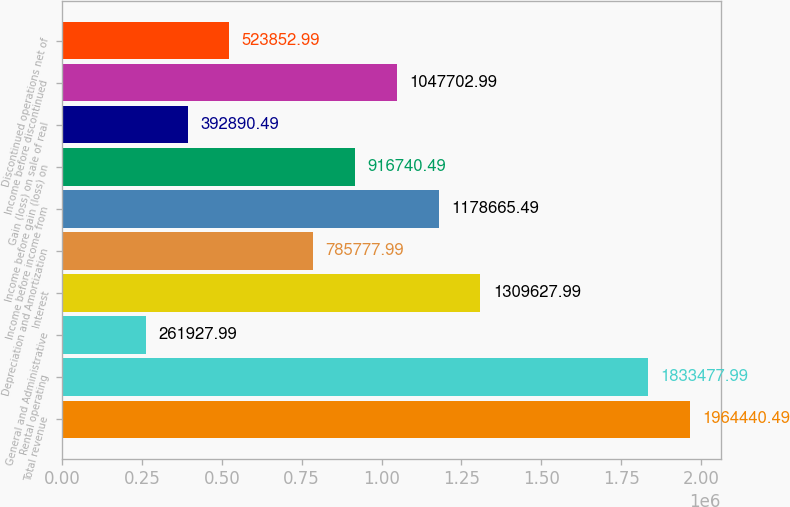Convert chart to OTSL. <chart><loc_0><loc_0><loc_500><loc_500><bar_chart><fcel>Total revenue<fcel>Rental operating<fcel>General and Administrative<fcel>Interest<fcel>Depreciation and Amortization<fcel>Income before income from<fcel>Income before gain (loss) on<fcel>Gain (loss) on sale of real<fcel>Income before discontinued<fcel>Discontinued operations net of<nl><fcel>1.96444e+06<fcel>1.83348e+06<fcel>261928<fcel>1.30963e+06<fcel>785778<fcel>1.17867e+06<fcel>916740<fcel>392890<fcel>1.0477e+06<fcel>523853<nl></chart> 